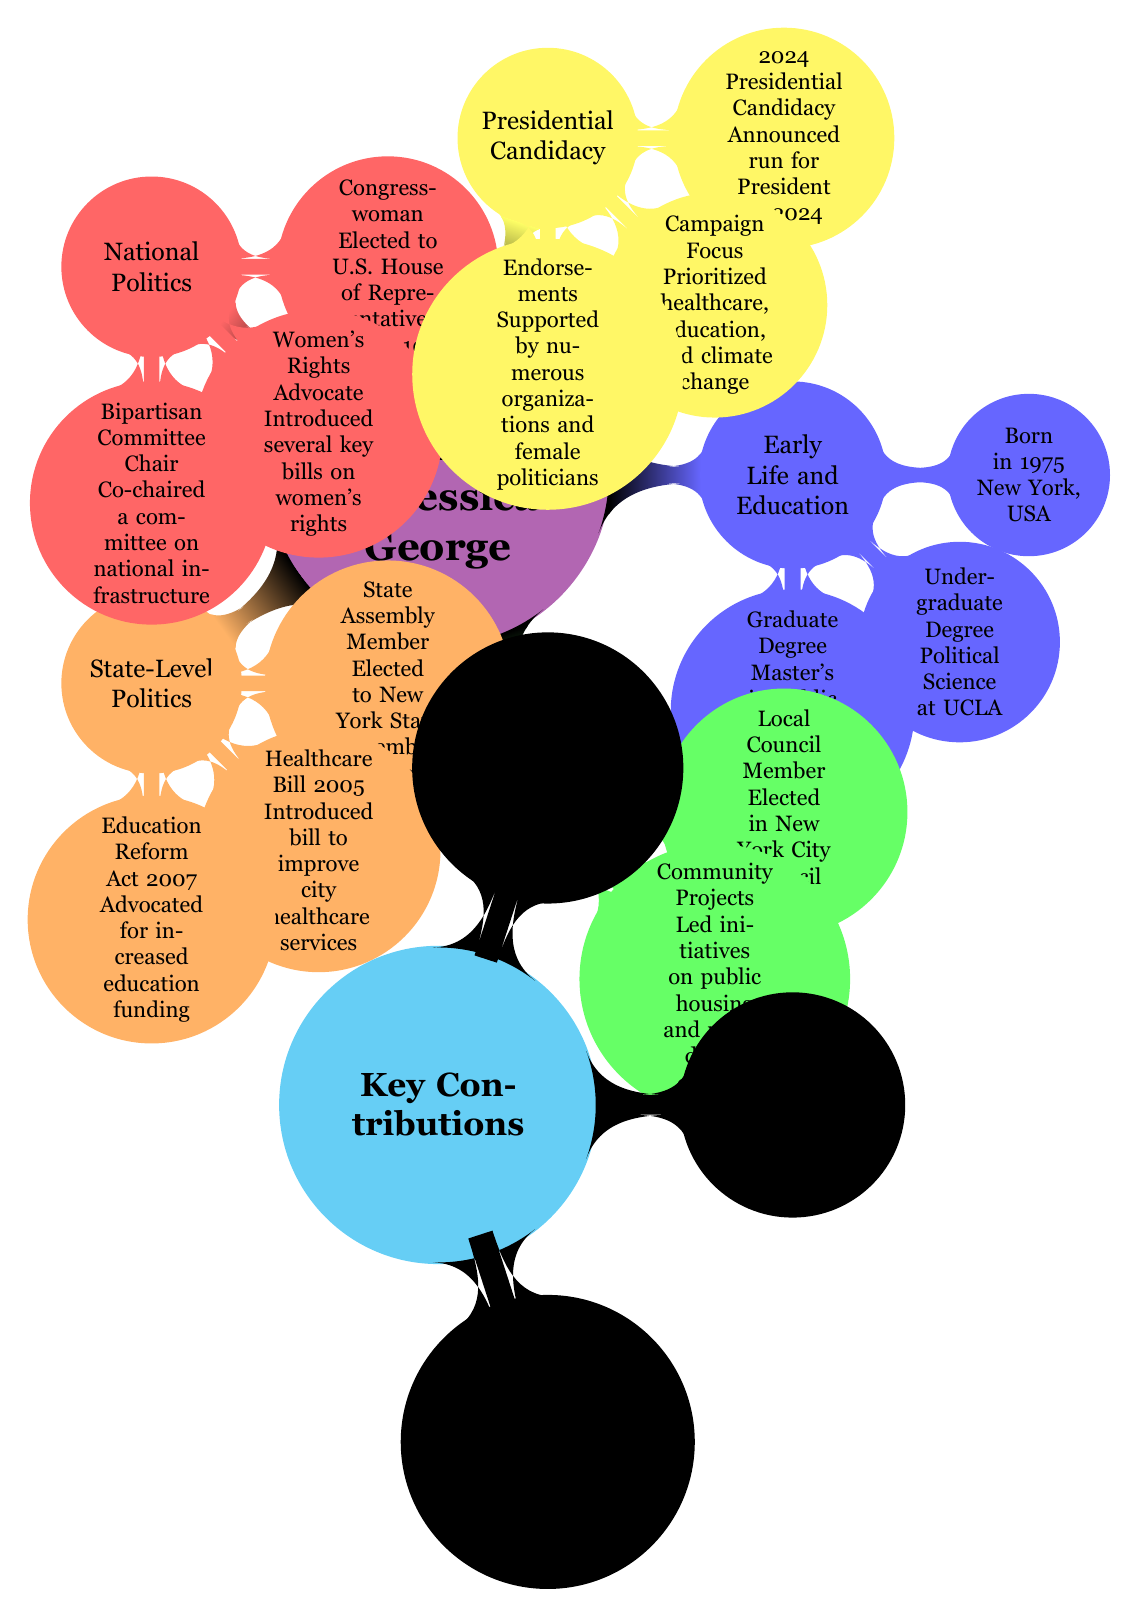What year was Jessica George born? The diagram states that Jessica George was born in 1975 in New York, USA.
Answer: 1975 How many key contributions are listed in the mind map? There are three key contributions listed under the "Key Contributions" section of the mind map.
Answer: 3 What was Jessica George's position when she was first elected? The mind map shows that she was elected as a local council member in the New York City Council in 1999.
Answer: Local Council Member What major legislation did Jessica George introduce in 2005? According to the diagram, Jessica George introduced a healthcare bill to improve city healthcare services in 2005.
Answer: Healthcare Bill What is the primary focus of Jessica George's 2024 presidential campaign? The diagram specifies that her campaign prioritized healthcare, education, and climate change.
Answer: Healthcare, education, and climate change How many phases are there in Jessica George's political journey depicted in the diagram? The mind map highlights four main phases in Jessica George's political journey: Early Life and Education, Entry into Politics, State-Level Politics, and National Politics, along with Presidential Candidacy.
Answer: 4 Which act did Jessica George champion in 2020? The diagram indicates that she championed the Equal Pay Act in 2020 as part of her key contributions.
Answer: Equal Pay Act What was Jessica George's role in national politics? She held the position of Congresswoman after being elected to the U.S. House of Representatives in 2010, as shown in the mind map.
Answer: Congresswoman In which year did Jessica George announce her presidential candidacy? The diagram clearly states that she announced her candidacy for President in 2024.
Answer: 2024 